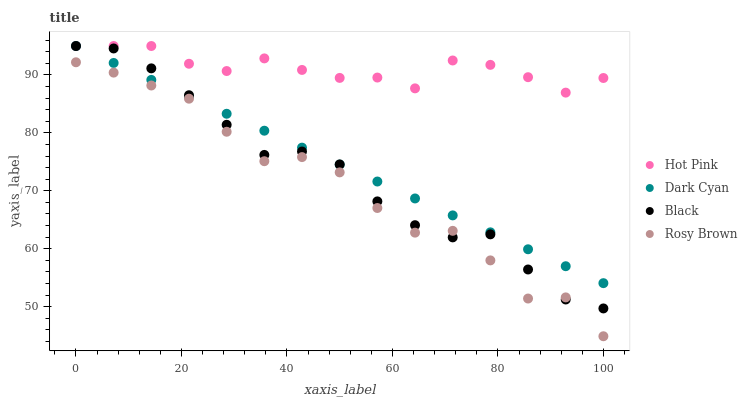Does Rosy Brown have the minimum area under the curve?
Answer yes or no. Yes. Does Hot Pink have the maximum area under the curve?
Answer yes or no. Yes. Does Hot Pink have the minimum area under the curve?
Answer yes or no. No. Does Rosy Brown have the maximum area under the curve?
Answer yes or no. No. Is Dark Cyan the smoothest?
Answer yes or no. Yes. Is Rosy Brown the roughest?
Answer yes or no. Yes. Is Hot Pink the smoothest?
Answer yes or no. No. Is Hot Pink the roughest?
Answer yes or no. No. Does Rosy Brown have the lowest value?
Answer yes or no. Yes. Does Hot Pink have the lowest value?
Answer yes or no. No. Does Black have the highest value?
Answer yes or no. Yes. Does Rosy Brown have the highest value?
Answer yes or no. No. Is Rosy Brown less than Dark Cyan?
Answer yes or no. Yes. Is Hot Pink greater than Rosy Brown?
Answer yes or no. Yes. Does Hot Pink intersect Dark Cyan?
Answer yes or no. Yes. Is Hot Pink less than Dark Cyan?
Answer yes or no. No. Is Hot Pink greater than Dark Cyan?
Answer yes or no. No. Does Rosy Brown intersect Dark Cyan?
Answer yes or no. No. 